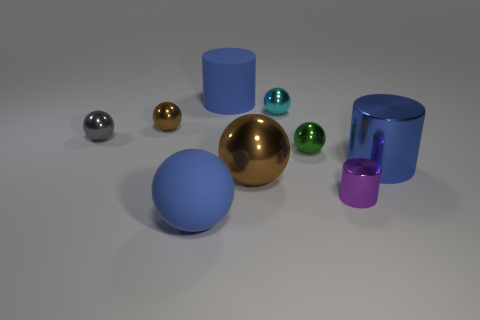Subtract all green spheres. How many spheres are left? 5 Subtract 3 balls. How many balls are left? 3 Subtract all brown metal balls. How many balls are left? 4 Subtract all cyan balls. Subtract all gray cubes. How many balls are left? 5 Subtract all spheres. How many objects are left? 3 Add 9 small gray shiny balls. How many small gray shiny balls are left? 10 Add 2 big purple metallic things. How many big purple metallic things exist? 2 Subtract 0 cyan cubes. How many objects are left? 9 Subtract all small red metallic cylinders. Subtract all blue matte things. How many objects are left? 7 